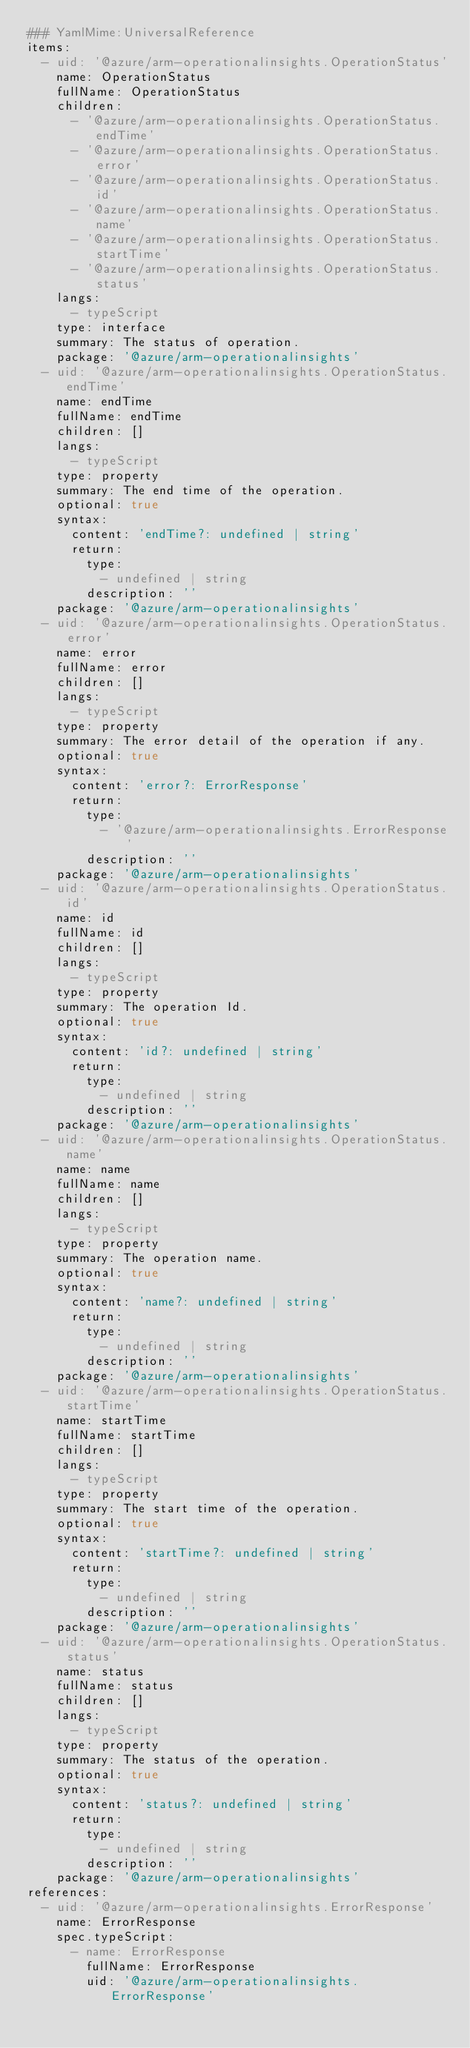Convert code to text. <code><loc_0><loc_0><loc_500><loc_500><_YAML_>### YamlMime:UniversalReference
items:
  - uid: '@azure/arm-operationalinsights.OperationStatus'
    name: OperationStatus
    fullName: OperationStatus
    children:
      - '@azure/arm-operationalinsights.OperationStatus.endTime'
      - '@azure/arm-operationalinsights.OperationStatus.error'
      - '@azure/arm-operationalinsights.OperationStatus.id'
      - '@azure/arm-operationalinsights.OperationStatus.name'
      - '@azure/arm-operationalinsights.OperationStatus.startTime'
      - '@azure/arm-operationalinsights.OperationStatus.status'
    langs:
      - typeScript
    type: interface
    summary: The status of operation.
    package: '@azure/arm-operationalinsights'
  - uid: '@azure/arm-operationalinsights.OperationStatus.endTime'
    name: endTime
    fullName: endTime
    children: []
    langs:
      - typeScript
    type: property
    summary: The end time of the operation.
    optional: true
    syntax:
      content: 'endTime?: undefined | string'
      return:
        type:
          - undefined | string
        description: ''
    package: '@azure/arm-operationalinsights'
  - uid: '@azure/arm-operationalinsights.OperationStatus.error'
    name: error
    fullName: error
    children: []
    langs:
      - typeScript
    type: property
    summary: The error detail of the operation if any.
    optional: true
    syntax:
      content: 'error?: ErrorResponse'
      return:
        type:
          - '@azure/arm-operationalinsights.ErrorResponse'
        description: ''
    package: '@azure/arm-operationalinsights'
  - uid: '@azure/arm-operationalinsights.OperationStatus.id'
    name: id
    fullName: id
    children: []
    langs:
      - typeScript
    type: property
    summary: The operation Id.
    optional: true
    syntax:
      content: 'id?: undefined | string'
      return:
        type:
          - undefined | string
        description: ''
    package: '@azure/arm-operationalinsights'
  - uid: '@azure/arm-operationalinsights.OperationStatus.name'
    name: name
    fullName: name
    children: []
    langs:
      - typeScript
    type: property
    summary: The operation name.
    optional: true
    syntax:
      content: 'name?: undefined | string'
      return:
        type:
          - undefined | string
        description: ''
    package: '@azure/arm-operationalinsights'
  - uid: '@azure/arm-operationalinsights.OperationStatus.startTime'
    name: startTime
    fullName: startTime
    children: []
    langs:
      - typeScript
    type: property
    summary: The start time of the operation.
    optional: true
    syntax:
      content: 'startTime?: undefined | string'
      return:
        type:
          - undefined | string
        description: ''
    package: '@azure/arm-operationalinsights'
  - uid: '@azure/arm-operationalinsights.OperationStatus.status'
    name: status
    fullName: status
    children: []
    langs:
      - typeScript
    type: property
    summary: The status of the operation.
    optional: true
    syntax:
      content: 'status?: undefined | string'
      return:
        type:
          - undefined | string
        description: ''
    package: '@azure/arm-operationalinsights'
references:
  - uid: '@azure/arm-operationalinsights.ErrorResponse'
    name: ErrorResponse
    spec.typeScript:
      - name: ErrorResponse
        fullName: ErrorResponse
        uid: '@azure/arm-operationalinsights.ErrorResponse'
</code> 